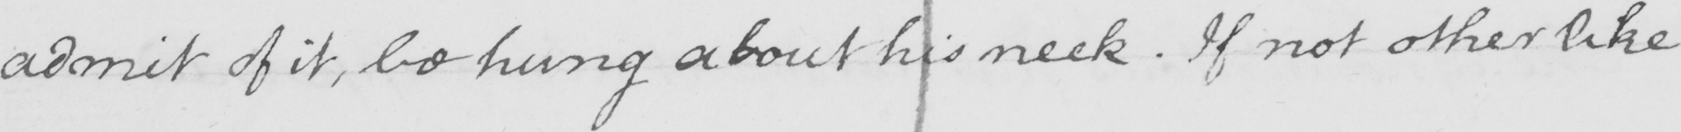What does this handwritten line say? admit of it , be hung about his neck . If not other like 